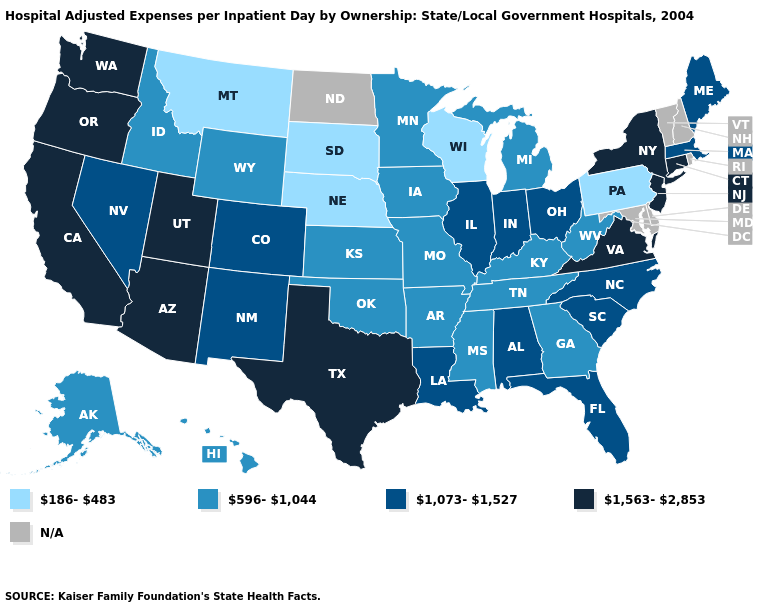Name the states that have a value in the range 1,073-1,527?
Concise answer only. Alabama, Colorado, Florida, Illinois, Indiana, Louisiana, Maine, Massachusetts, Nevada, New Mexico, North Carolina, Ohio, South Carolina. Is the legend a continuous bar?
Keep it brief. No. Which states have the lowest value in the USA?
Concise answer only. Montana, Nebraska, Pennsylvania, South Dakota, Wisconsin. Name the states that have a value in the range N/A?
Quick response, please. Delaware, Maryland, New Hampshire, North Dakota, Rhode Island, Vermont. What is the value of Nebraska?
Keep it brief. 186-483. Which states have the lowest value in the Northeast?
Give a very brief answer. Pennsylvania. Name the states that have a value in the range 1,563-2,853?
Keep it brief. Arizona, California, Connecticut, New Jersey, New York, Oregon, Texas, Utah, Virginia, Washington. What is the value of Washington?
Give a very brief answer. 1,563-2,853. How many symbols are there in the legend?
Short answer required. 5. Name the states that have a value in the range 596-1,044?
Answer briefly. Alaska, Arkansas, Georgia, Hawaii, Idaho, Iowa, Kansas, Kentucky, Michigan, Minnesota, Mississippi, Missouri, Oklahoma, Tennessee, West Virginia, Wyoming. Name the states that have a value in the range 186-483?
Concise answer only. Montana, Nebraska, Pennsylvania, South Dakota, Wisconsin. Which states have the highest value in the USA?
Short answer required. Arizona, California, Connecticut, New Jersey, New York, Oregon, Texas, Utah, Virginia, Washington. Does the first symbol in the legend represent the smallest category?
Write a very short answer. Yes. What is the highest value in the USA?
Keep it brief. 1,563-2,853. 